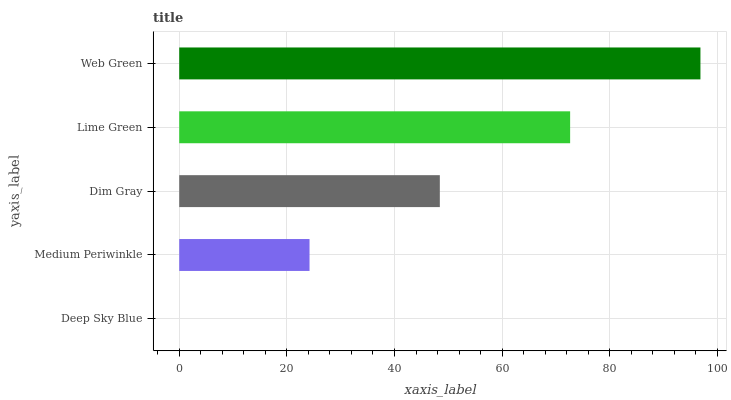Is Deep Sky Blue the minimum?
Answer yes or no. Yes. Is Web Green the maximum?
Answer yes or no. Yes. Is Medium Periwinkle the minimum?
Answer yes or no. No. Is Medium Periwinkle the maximum?
Answer yes or no. No. Is Medium Periwinkle greater than Deep Sky Blue?
Answer yes or no. Yes. Is Deep Sky Blue less than Medium Periwinkle?
Answer yes or no. Yes. Is Deep Sky Blue greater than Medium Periwinkle?
Answer yes or no. No. Is Medium Periwinkle less than Deep Sky Blue?
Answer yes or no. No. Is Dim Gray the high median?
Answer yes or no. Yes. Is Dim Gray the low median?
Answer yes or no. Yes. Is Web Green the high median?
Answer yes or no. No. Is Deep Sky Blue the low median?
Answer yes or no. No. 